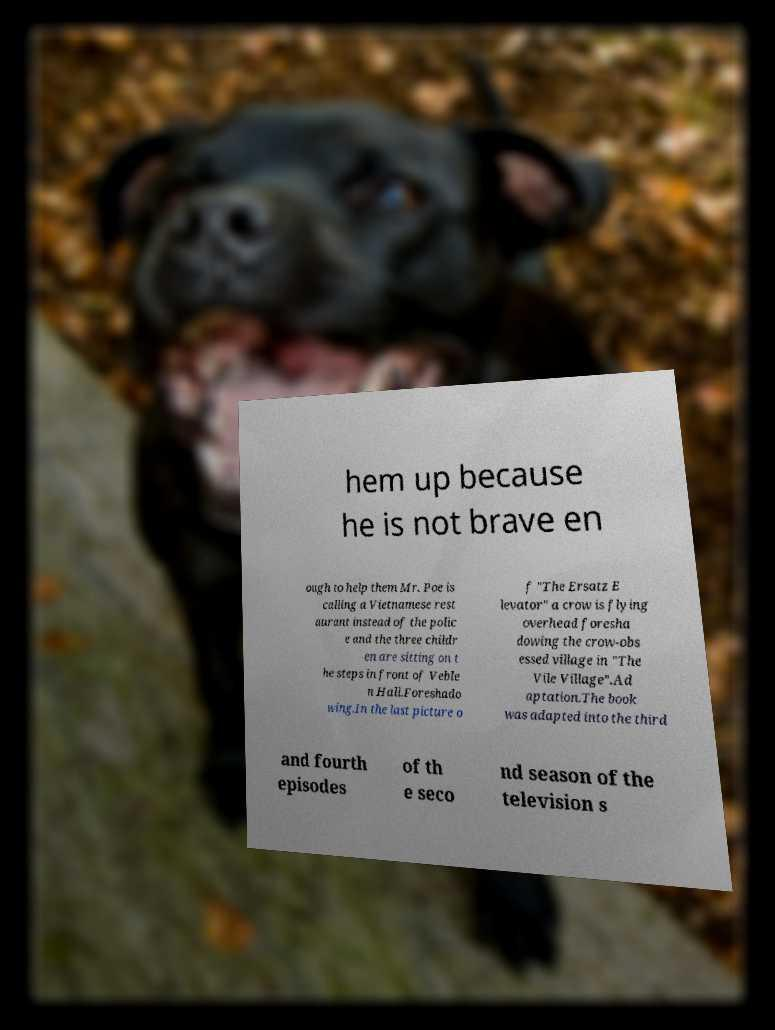Could you extract and type out the text from this image? hem up because he is not brave en ough to help them Mr. Poe is calling a Vietnamese rest aurant instead of the polic e and the three childr en are sitting on t he steps in front of Veble n Hall.Foreshado wing.In the last picture o f "The Ersatz E levator" a crow is flying overhead foresha dowing the crow-obs essed village in "The Vile Village".Ad aptation.The book was adapted into the third and fourth episodes of th e seco nd season of the television s 